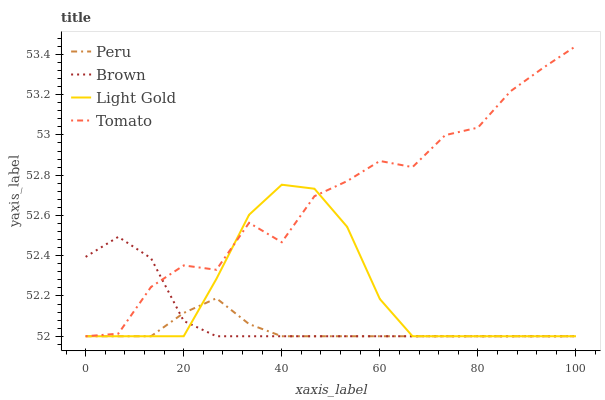Does Peru have the minimum area under the curve?
Answer yes or no. Yes. Does Tomato have the maximum area under the curve?
Answer yes or no. Yes. Does Brown have the minimum area under the curve?
Answer yes or no. No. Does Brown have the maximum area under the curve?
Answer yes or no. No. Is Peru the smoothest?
Answer yes or no. Yes. Is Tomato the roughest?
Answer yes or no. Yes. Is Brown the smoothest?
Answer yes or no. No. Is Brown the roughest?
Answer yes or no. No. Does Tomato have the lowest value?
Answer yes or no. Yes. Does Tomato have the highest value?
Answer yes or no. Yes. Does Brown have the highest value?
Answer yes or no. No. Does Brown intersect Light Gold?
Answer yes or no. Yes. Is Brown less than Light Gold?
Answer yes or no. No. Is Brown greater than Light Gold?
Answer yes or no. No. 